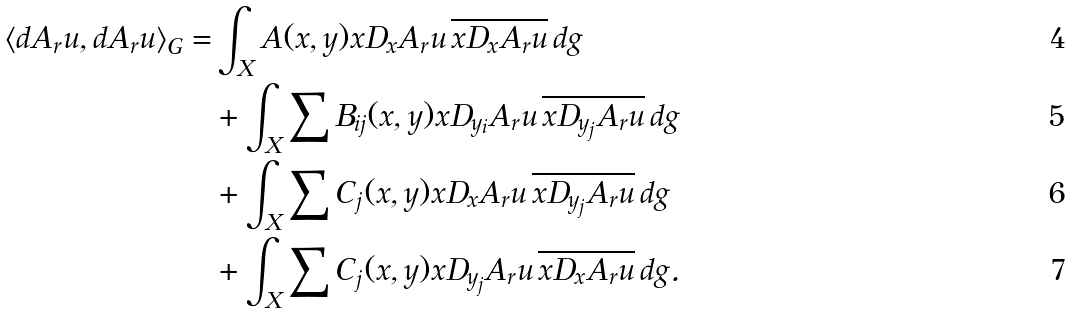Convert formula to latex. <formula><loc_0><loc_0><loc_500><loc_500>\langle d A _ { r } u , d A _ { r } u \rangle _ { G } = & \int _ { X } A ( x , y ) x D _ { x } A _ { r } u \, \overline { x D _ { x } A _ { r } u } \, d g \\ & + \int _ { X } \sum B _ { i j } ( x , y ) x D _ { y _ { i } } A _ { r } u \, \overline { x D _ { y _ { j } } A _ { r } u } \, d g \\ & + \int _ { X } \sum C _ { j } ( x , y ) x D _ { x } A _ { r } u \, \overline { x D _ { y _ { j } } A _ { r } u } \, d g \\ & + \int _ { X } \sum C _ { j } ( x , y ) x D _ { y _ { j } } A _ { r } u \, \overline { x D _ { x } A _ { r } u } \, d g .</formula> 